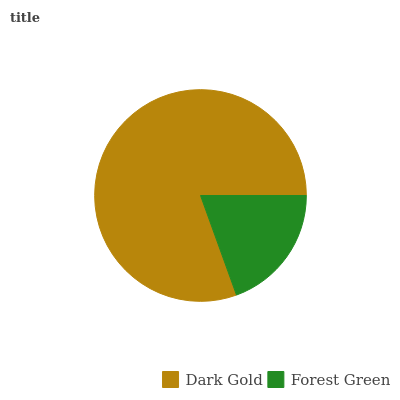Is Forest Green the minimum?
Answer yes or no. Yes. Is Dark Gold the maximum?
Answer yes or no. Yes. Is Forest Green the maximum?
Answer yes or no. No. Is Dark Gold greater than Forest Green?
Answer yes or no. Yes. Is Forest Green less than Dark Gold?
Answer yes or no. Yes. Is Forest Green greater than Dark Gold?
Answer yes or no. No. Is Dark Gold less than Forest Green?
Answer yes or no. No. Is Dark Gold the high median?
Answer yes or no. Yes. Is Forest Green the low median?
Answer yes or no. Yes. Is Forest Green the high median?
Answer yes or no. No. Is Dark Gold the low median?
Answer yes or no. No. 